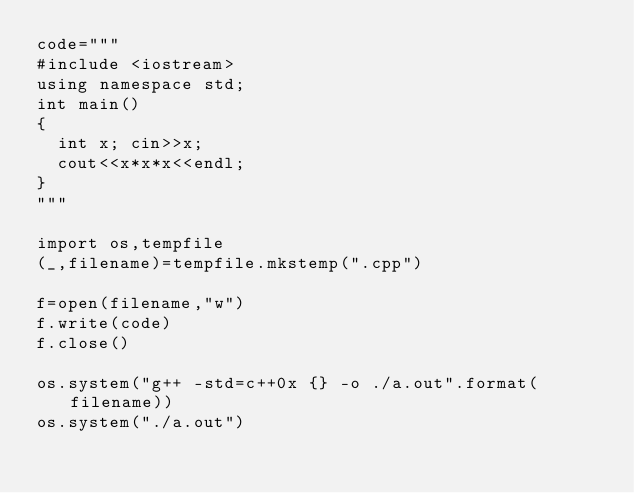<code> <loc_0><loc_0><loc_500><loc_500><_Python_>code="""
#include <iostream>
using namespace std;
int main()
{
  int x; cin>>x;
  cout<<x*x*x<<endl;
}
"""

import os,tempfile
(_,filename)=tempfile.mkstemp(".cpp")

f=open(filename,"w")
f.write(code)
f.close()

os.system("g++ -std=c++0x {} -o ./a.out".format(filename))
os.system("./a.out")</code> 